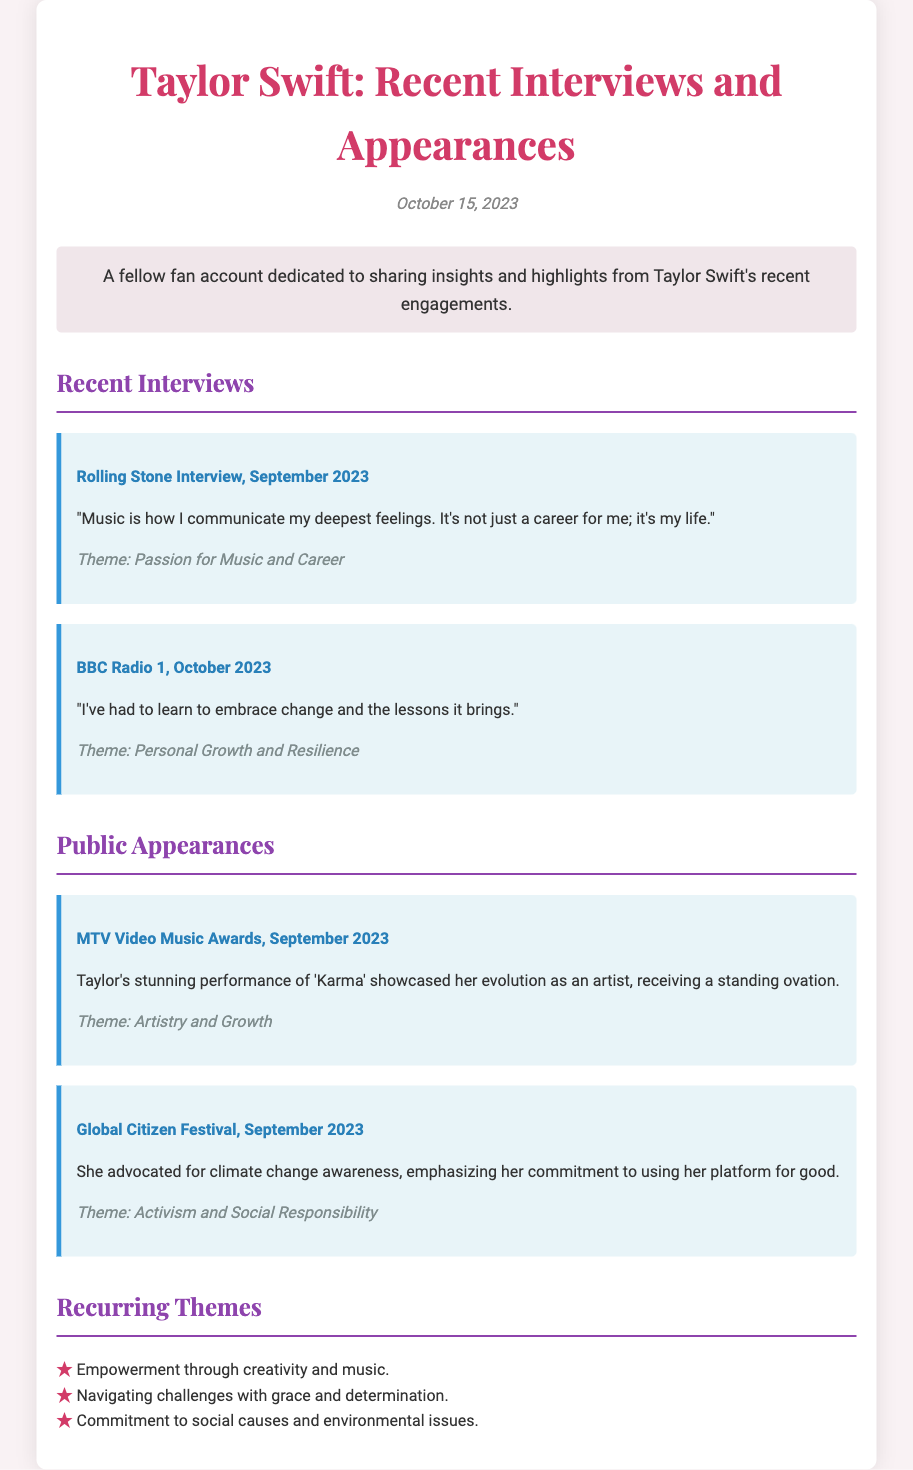what is the date of the document? The document mentions the date at the top, specifically as "October 15, 2023."
Answer: October 15, 2023 who conducted the interview where Taylor discussed her passion for music? The document specifies that the interview was conducted by "Rolling Stone."
Answer: Rolling Stone what theme is associated with Taylor's quote about embracing change? The document lists the theme accompanying her quote as "Personal Growth and Resilience."
Answer: Personal Growth and Resilience which event featured Taylor's performance of 'Karma'? The document states that the performance of 'Karma' took place at the "MTV Video Music Awards."
Answer: MTV Video Music Awards what cause did Taylor advocate for at the Global Citizen Festival? The document indicates that she advocated for "climate change awareness."
Answer: climate change awareness how many recurring themes are listed in the document? The document lists three recurring themes in the section titled "Recurring Themes."
Answer: 3 what is Taylor's perspective on music according to her Rolling Stone interview? The quote from the Rolling Stone interview reflects that "Music is how I communicate my deepest feelings."
Answer: communicate my deepest feelings which quote from Taylor highlights her commitment to social responsibility? The quote about advocating for climate change awareness at the Global Citizen Festival highlights her commitment.
Answer: climate change awareness 